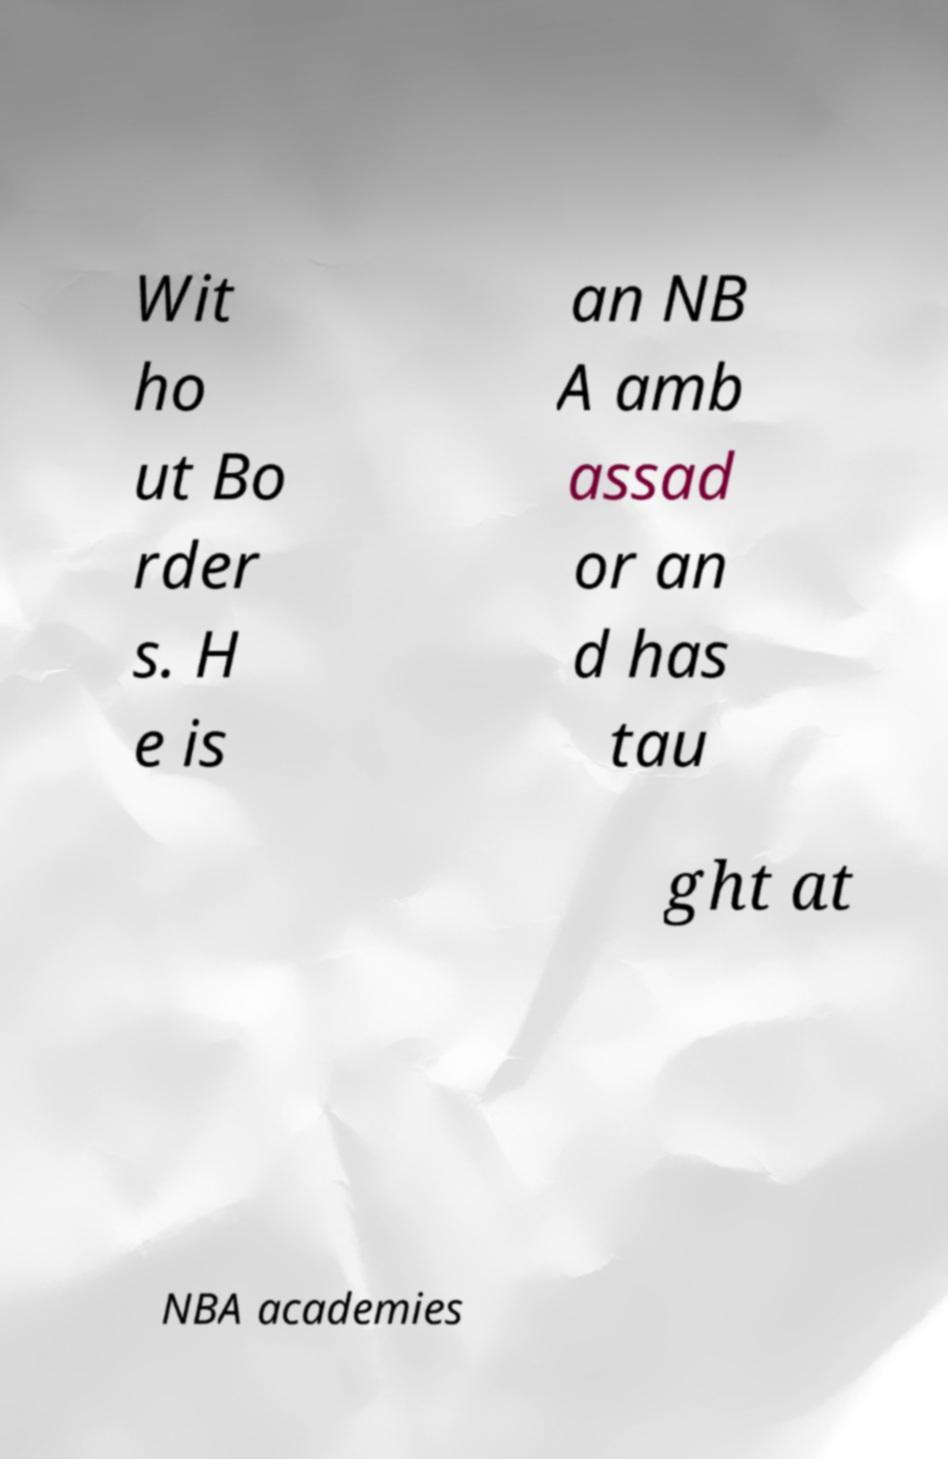Could you assist in decoding the text presented in this image and type it out clearly? Wit ho ut Bo rder s. H e is an NB A amb assad or an d has tau ght at NBA academies 